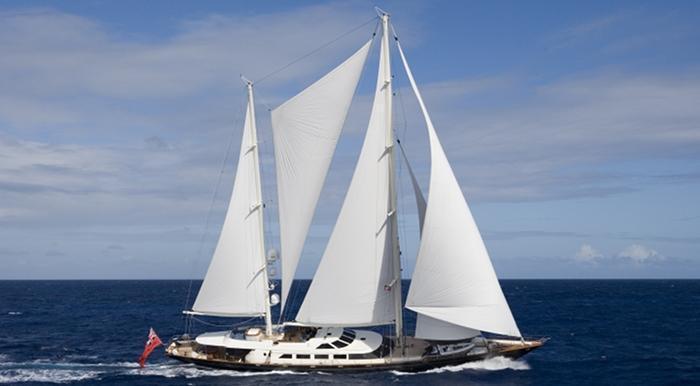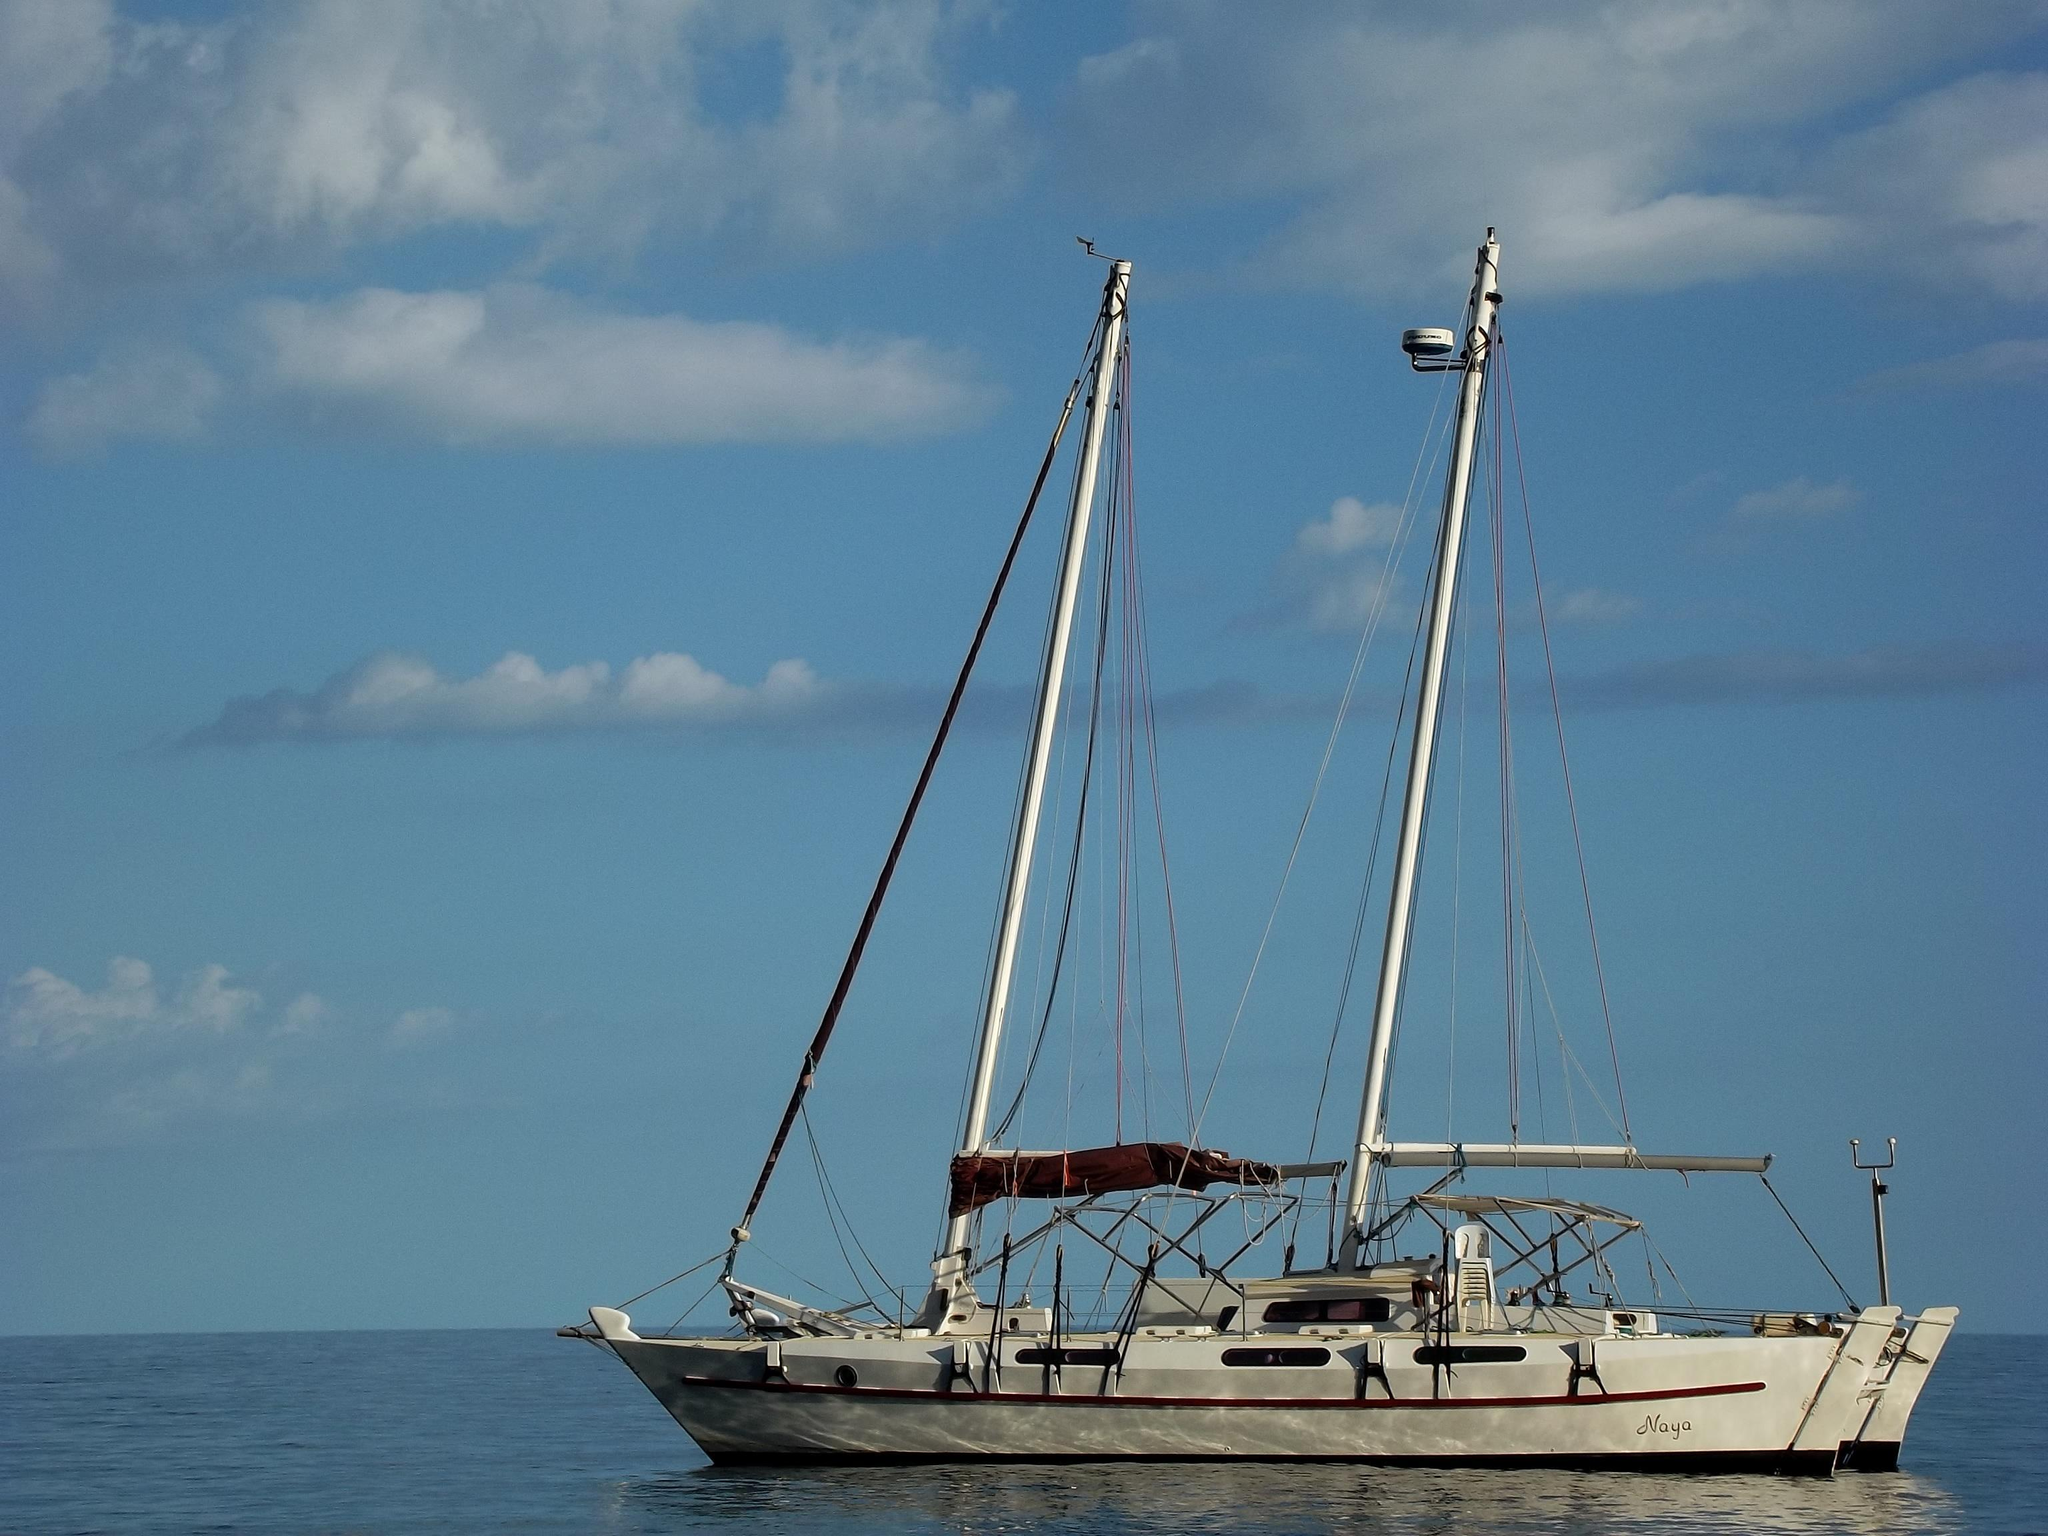The first image is the image on the left, the second image is the image on the right. Evaluate the accuracy of this statement regarding the images: "The sails on one of the ships is fully extended.". Is it true? Answer yes or no. Yes. The first image is the image on the left, the second image is the image on the right. Assess this claim about the two images: "A grassy hill is in the background of a sailboat.". Correct or not? Answer yes or no. No. 